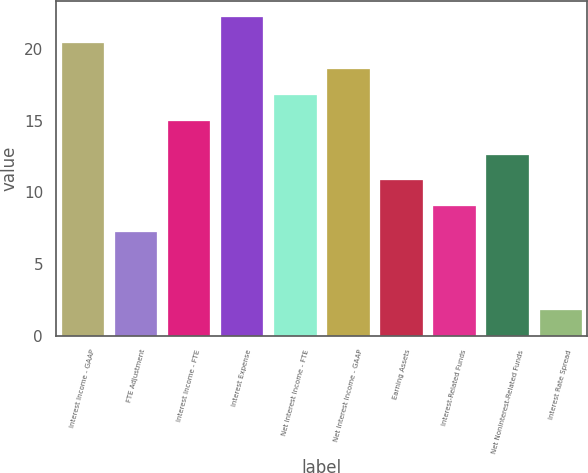Convert chart. <chart><loc_0><loc_0><loc_500><loc_500><bar_chart><fcel>Interest Income - GAAP<fcel>FTE Adjustment<fcel>Interest Income - FTE<fcel>Interest Expense<fcel>Net Interest Income - FTE<fcel>Net Interest Income - GAAP<fcel>Earning Assets<fcel>Interest-Related Funds<fcel>Net Noninterest-Related Funds<fcel>Interest Rate Spread<nl><fcel>20.4<fcel>7.22<fcel>15<fcel>22.2<fcel>16.8<fcel>18.6<fcel>10.82<fcel>9.02<fcel>12.62<fcel>1.82<nl></chart> 